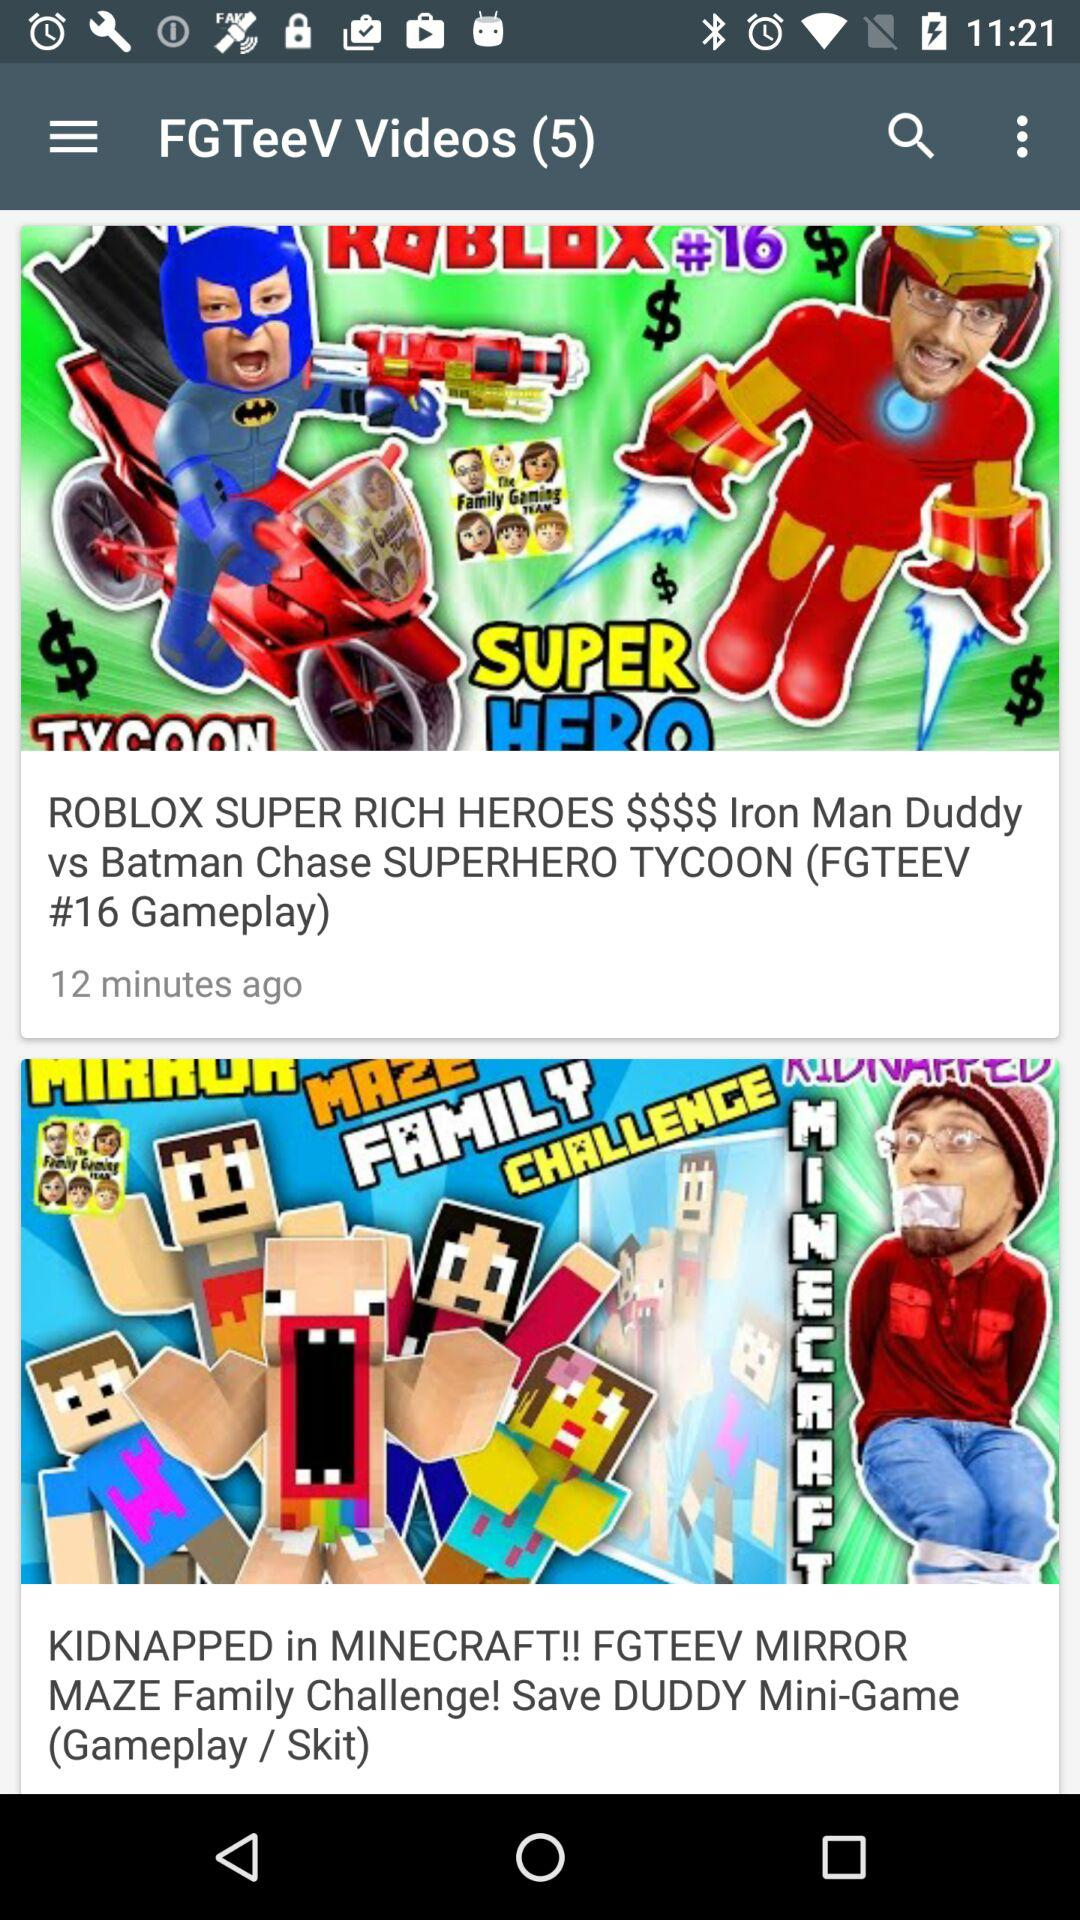What is the count of the videos? The count of the videos is 5. 